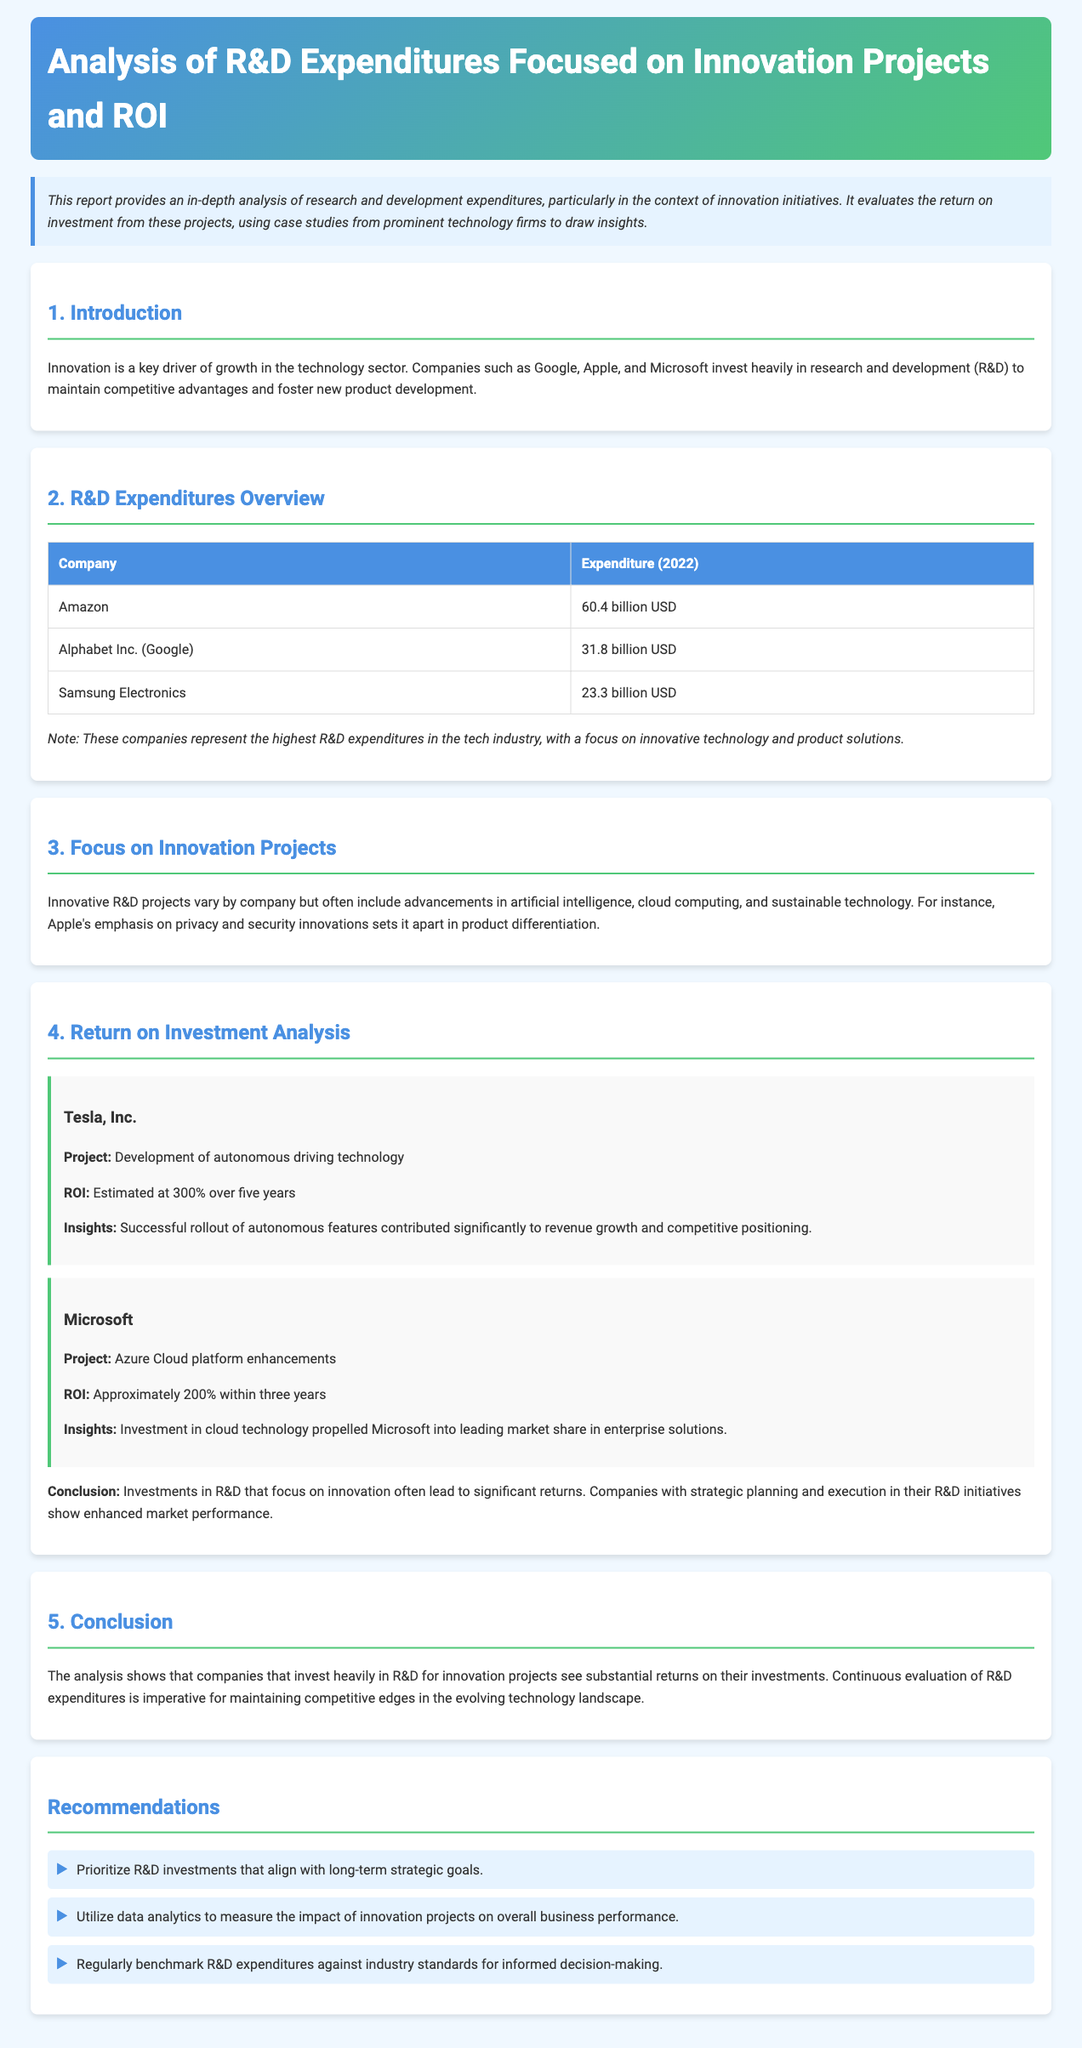What is the title of the report? The title of the report appears at the top of the document and is "Analysis of R&D Expenditures Focused on Innovation Projects and ROI."
Answer: Analysis of R&D Expenditures Focused on Innovation Projects and ROI Which company had the highest R&D expenditure in 2022? The document includes a table of R&D expenditures where Amazon is listed with the highest expenditure of 60.4 billion USD.
Answer: Amazon What was Tesla's estimated ROI for its autonomous driving technology project? The document mentions that Tesla's project ROI is estimated at 300% over five years.
Answer: 300% What is one area where companies focus their innovative R&D projects? In the document, advancements in artificial intelligence are mentioned as one focus area for innovative R&D projects.
Answer: artificial intelligence How much did Alphabet Inc. spend on R&D in 2022? The table lists Alphabet Inc. (Google) R&D expenditure as 31.8 billion USD for 2022.
Answer: 31.8 billion USD What is a recommendation for R&D investments? The document recommends prioritizing R&D investments that align with long-term strategic goals.
Answer: Align with long-term strategic goals What is the main conclusion regarding R&D investments? The conclusion states that companies investing in R&D for innovation often see substantial returns, highlighting the importance of continuous evaluation.
Answer: substantial returns Which two companies are highlighted for their projects and ROI in the report? The report highlights Tesla and Microsoft for their R&D projects and respective ROI figures.
Answer: Tesla and Microsoft 